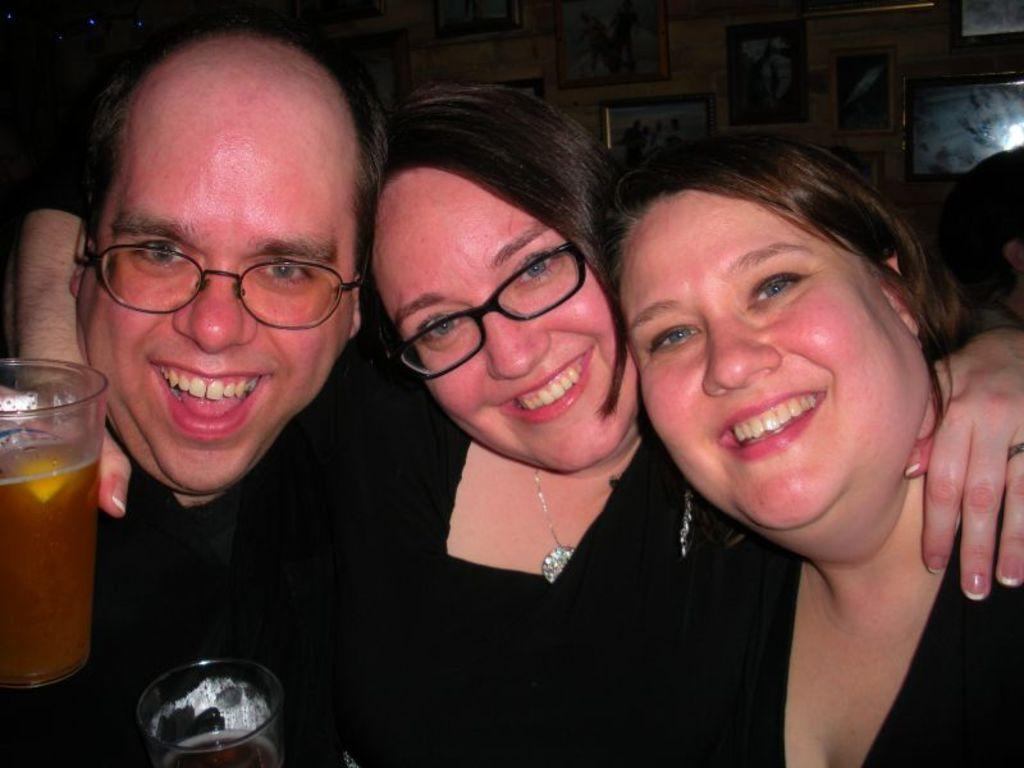How many people are in the image? There are people in the image, but the exact number is not specified. What are the people doing in the image? The people are sitting and smiling in the image. Can you describe any objects that the people are holding? One person is holding a beverage tumbler in their hands. What type of design can be seen on the top of the sky in the image? There is no mention of a design, top, or sky in the image, so this question cannot be answered definitively. 